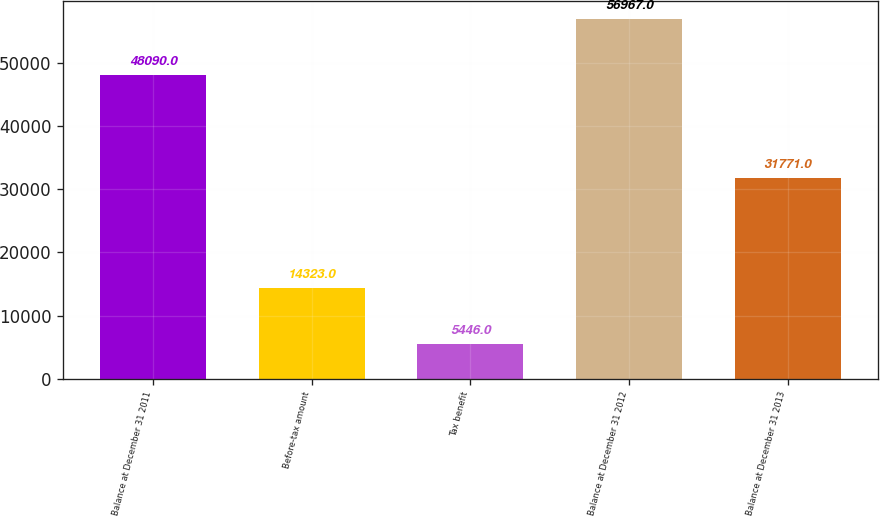Convert chart to OTSL. <chart><loc_0><loc_0><loc_500><loc_500><bar_chart><fcel>Balance at December 31 2011<fcel>Before-tax amount<fcel>Tax benefit<fcel>Balance at December 31 2012<fcel>Balance at December 31 2013<nl><fcel>48090<fcel>14323<fcel>5446<fcel>56967<fcel>31771<nl></chart> 